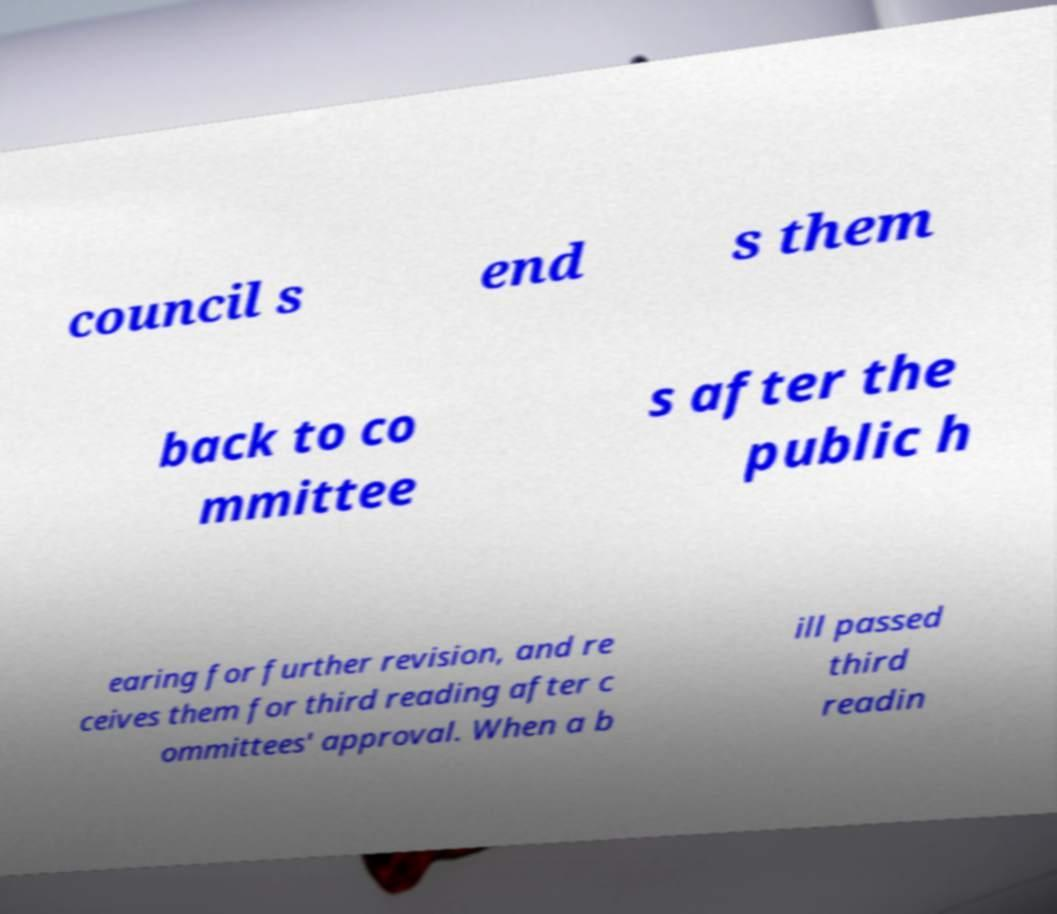For documentation purposes, I need the text within this image transcribed. Could you provide that? council s end s them back to co mmittee s after the public h earing for further revision, and re ceives them for third reading after c ommittees' approval. When a b ill passed third readin 